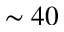<formula> <loc_0><loc_0><loc_500><loc_500>\sim 4 0</formula> 